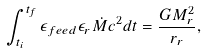Convert formula to latex. <formula><loc_0><loc_0><loc_500><loc_500>\int _ { t _ { i } } ^ { t _ { f } } \epsilon _ { f e e d } \epsilon _ { r } \dot { M } c ^ { 2 } d t = \frac { G M _ { r } ^ { 2 } } { r _ { r } } ,</formula> 